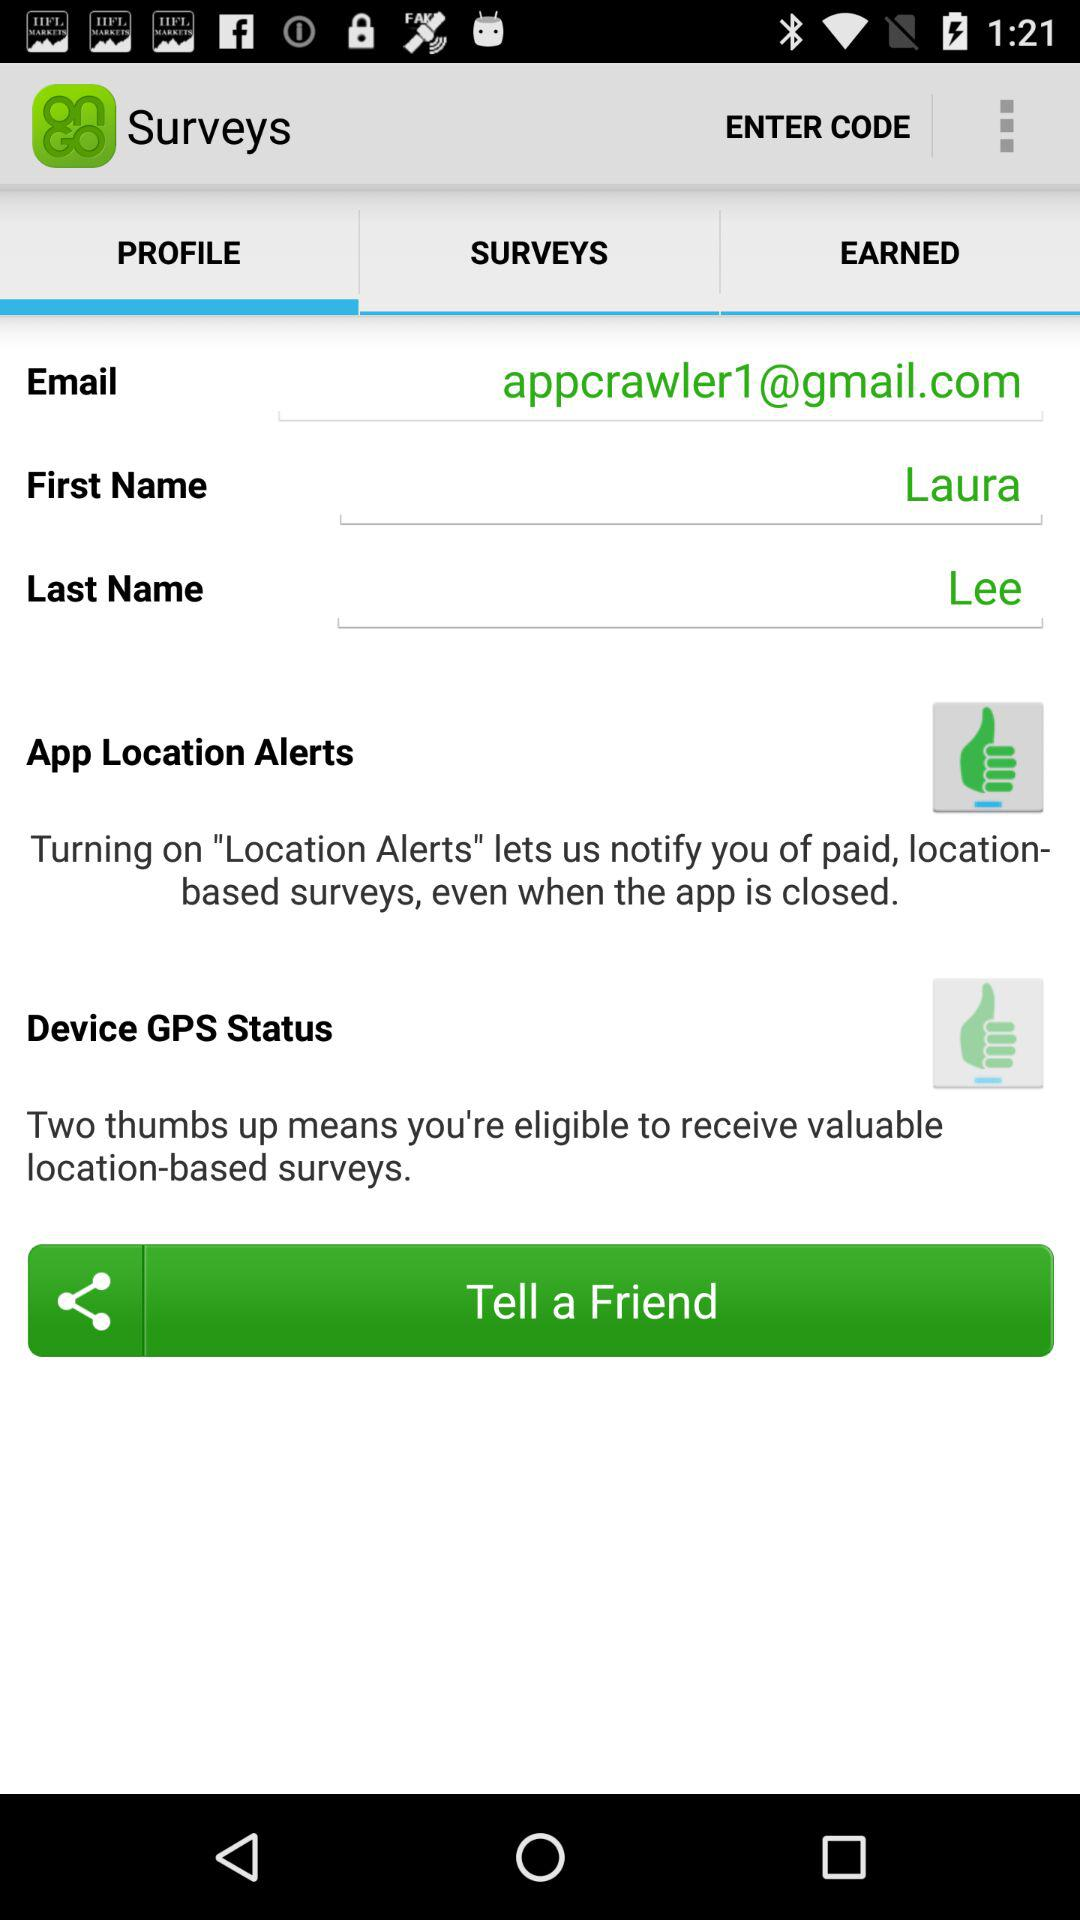What is the name? The name is Laura Lee. 